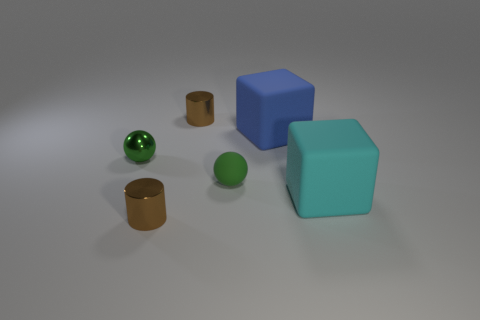Add 2 green metallic things. How many objects exist? 8 Subtract all tiny spheres. Subtract all purple rubber things. How many objects are left? 4 Add 6 green rubber spheres. How many green rubber spheres are left? 7 Add 2 big matte cubes. How many big matte cubes exist? 4 Subtract 2 green balls. How many objects are left? 4 Subtract all cubes. How many objects are left? 4 